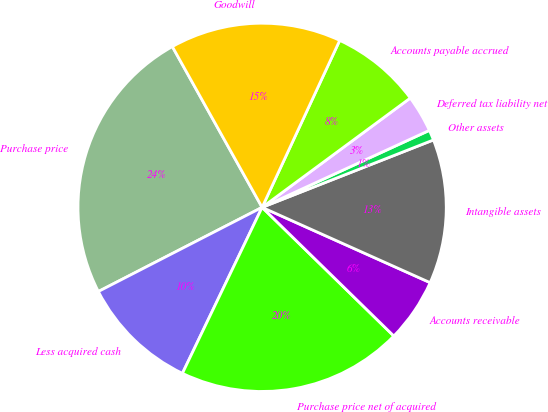Convert chart. <chart><loc_0><loc_0><loc_500><loc_500><pie_chart><fcel>Purchase price<fcel>Less acquired cash<fcel>Purchase price net of acquired<fcel>Accounts receivable<fcel>Intangible assets<fcel>Other assets<fcel>Deferred tax liability net<fcel>Accounts payable accrued<fcel>Goodwill<nl><fcel>24.45%<fcel>10.32%<fcel>19.81%<fcel>5.61%<fcel>12.67%<fcel>0.9%<fcel>3.25%<fcel>7.96%<fcel>15.03%<nl></chart> 